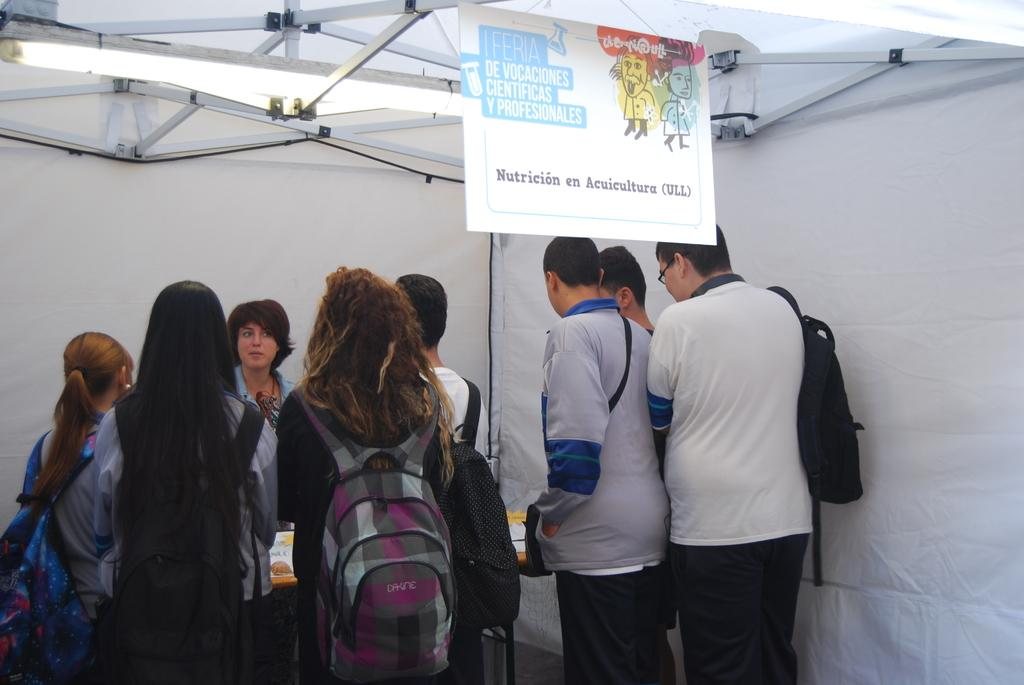What can be seen hanging on the wall in the image? There is a poster in the image. What type of lighting is present in the image? There is a tube light in the image. What objects are present that resemble long, thin bars? There are rods in the image. What temporary shelter is visible in the image? There is a tent in the image. What are the people in the image carrying? The group of people in the image are carrying bags. What is the position of the people in the image? The people are standing in the image. What is on the table in the image? There is a table with papers on it in the image. What type of cloth is draped over the tent in the image? There is no cloth draped over the tent in the image; it is a simple tent without any additional coverings. What type of harmony is being practiced by the people in the image? There is no indication of any musical or social harmony in the image; it simply shows a group of people standing with bags. 